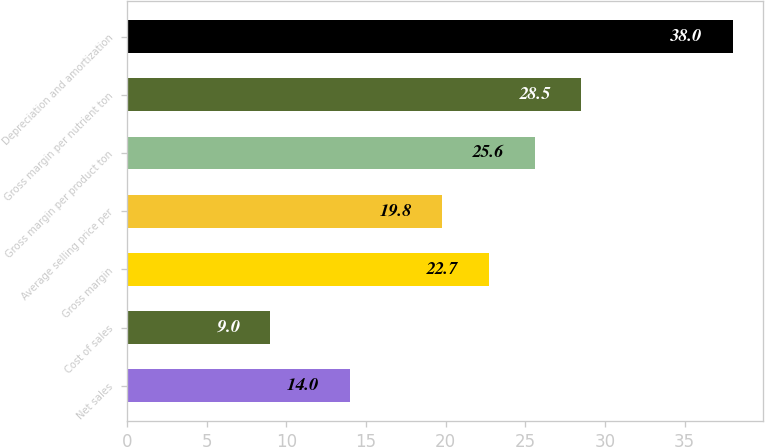Convert chart. <chart><loc_0><loc_0><loc_500><loc_500><bar_chart><fcel>Net sales<fcel>Cost of sales<fcel>Gross margin<fcel>Average selling price per<fcel>Gross margin per product ton<fcel>Gross margin per nutrient ton<fcel>Depreciation and amortization<nl><fcel>14<fcel>9<fcel>22.7<fcel>19.8<fcel>25.6<fcel>28.5<fcel>38<nl></chart> 